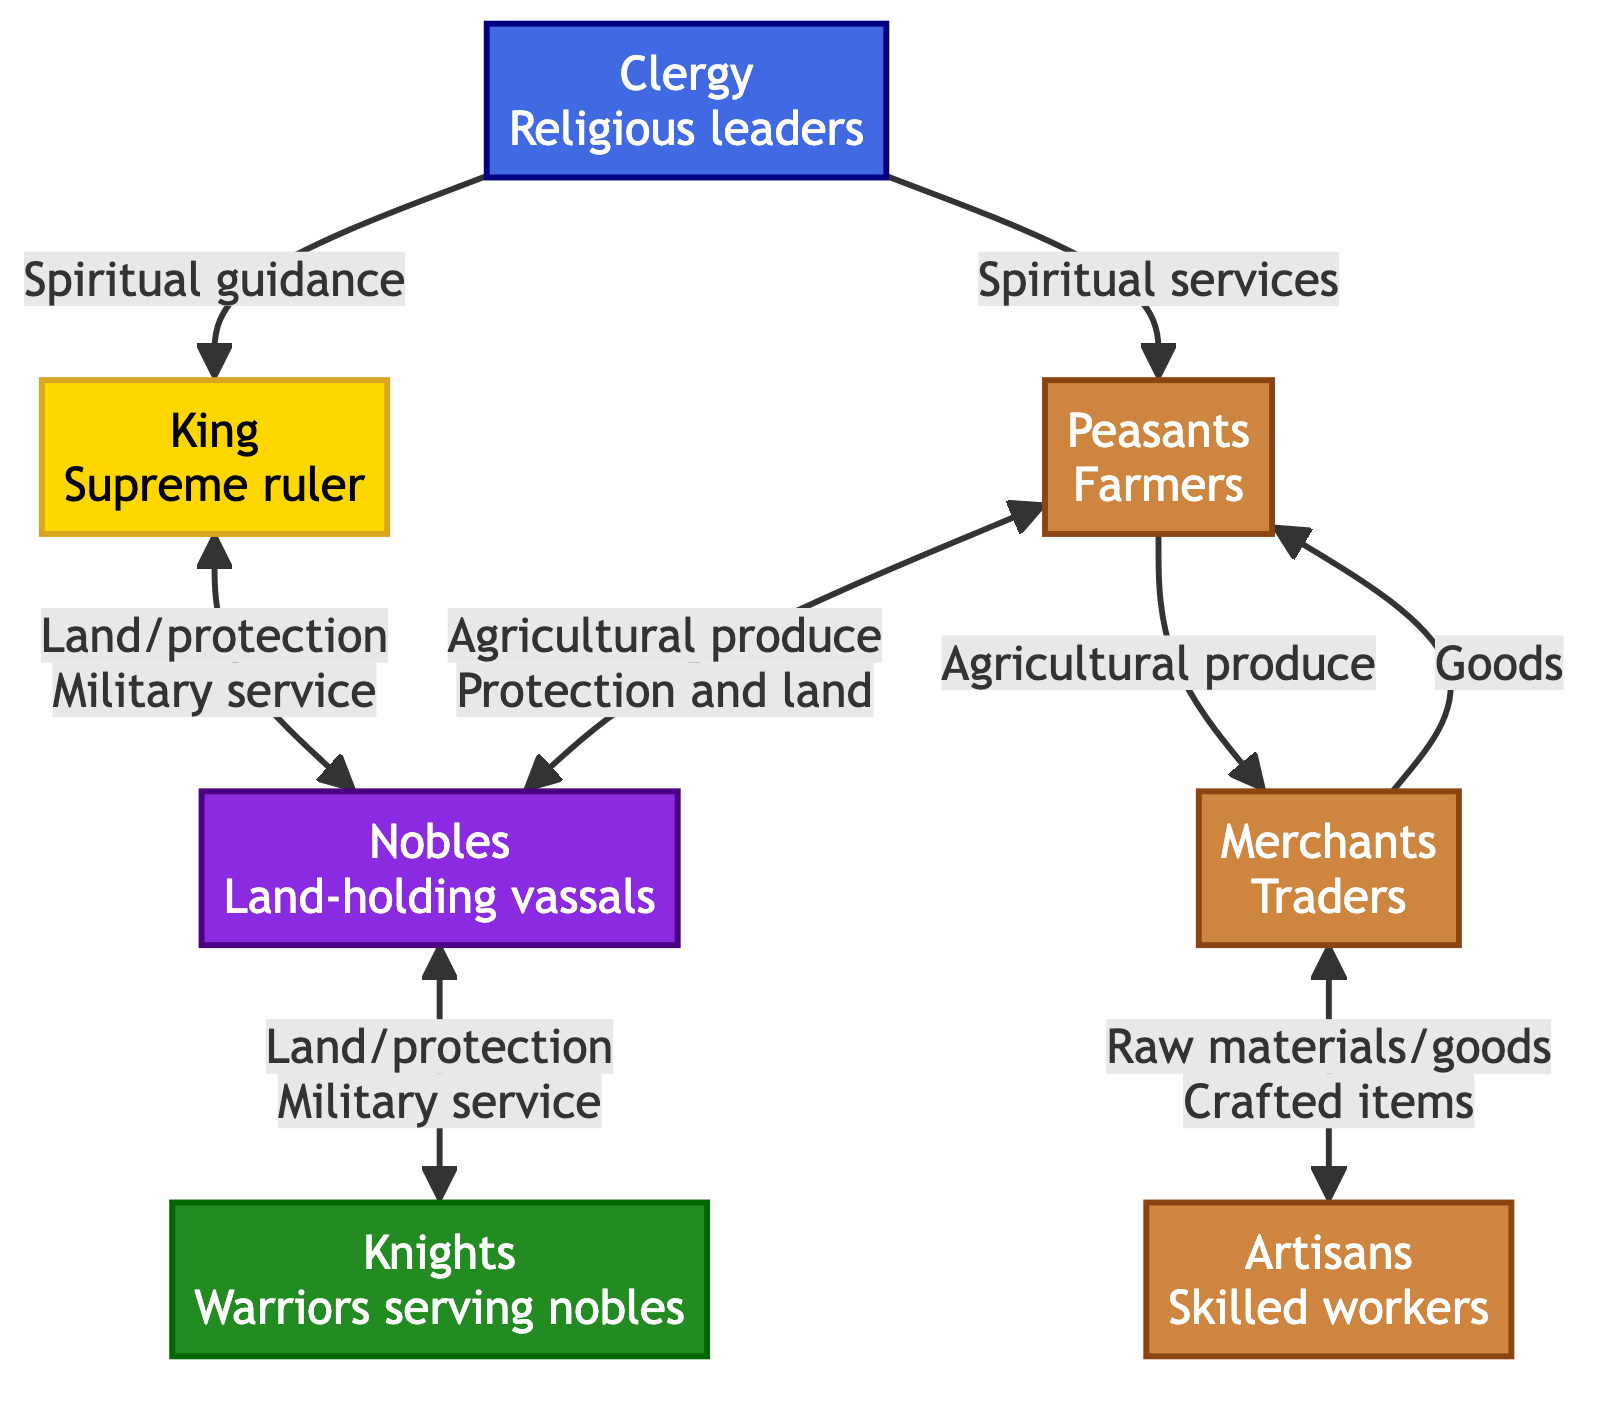What is the top node in the hierarchy? The top node is labeled "King" and represents the supreme ruler in the hierarchy. It is positioned at the apex of the diagram, signifying its highest status.
Answer: King How many distinct roles are represented in this diagram? The diagram lists a total of six roles: King, Nobles, Knights, Clergy, Merchants, and Peasants. By counting each unique node, we determine the total number of distinct roles.
Answer: 6 What type of relationship exists between Nobles and Knights? The relationship is defined as "Land/protection" and "Military service," indicating that nobles provide land and protection to knights in exchange for military service.
Answer: Land/protection, Military service Which social group provides spiritual guidance to the King? The social group that provides spiritual guidance to the King is the Clergy. This connection is illustrated by a directed arrow that signifies the flow of spiritual support.
Answer: Clergy What do Merchants provide to Peasants? Merchants provide goods to Peasants. The diagram directly indicates that there is a flow of goods from merchants to peasants, highlighting their economic interaction.
Answer: Goods What is the role of Artisans in relation to Merchants? Artisans trade crafted items for raw materials with Merchants. This relationship illustrates the exchange of goods and highlights the interconnectedness of these social roles.
Answer: Crafted items How does the Peasantry interact with Nobles? Peasants send agricultural produce to Nobles in exchange for protection and land. This bidirectional relationship indicates the dependency between these two groups.
Answer: Agricultural produce, Protection and land Which group has a direct relationship with both Nobles and Peasants? The Clergy has a direct relationship with both Nobles (providing spiritual guidance) and Peasants (providing spiritual services). This illustrates the Clergy's role in connecting different social layers.
Answer: Clergy How many connections are there emanating from the Clergy node? There are two relationships emanating from the Clergy node: one to the King for spiritual guidance, and one to the Peasants for spiritual services. This counts the directed arrows leading from the Clergy.
Answer: 2 